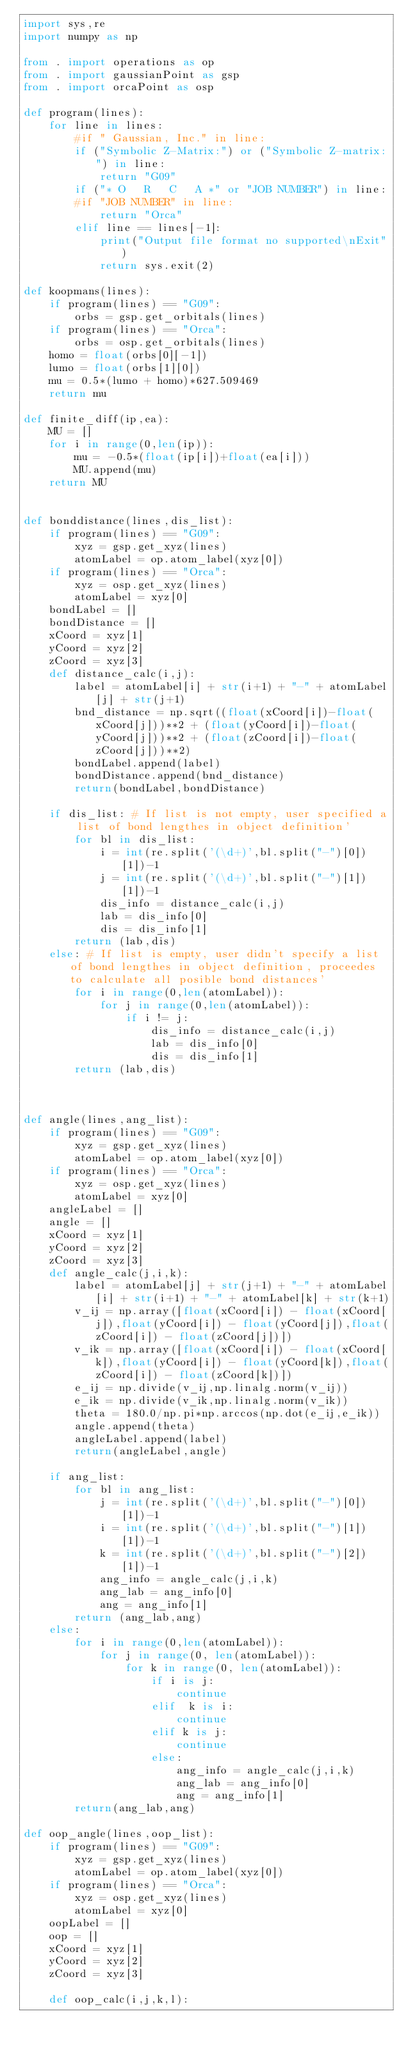Convert code to text. <code><loc_0><loc_0><loc_500><loc_500><_Python_>import sys,re
import numpy as np

from . import operations as op
from . import gaussianPoint as gsp
from . import orcaPoint as osp

def program(lines):
    for line in lines:
        #if " Gaussian, Inc." in line:
        if ("Symbolic Z-Matrix:") or ("Symbolic Z-matrix:") in line:
            return "G09"
        if ("* O   R   C   A *" or "JOB NUMBER") in line:
        #if "JOB NUMBER" in line:
            return "Orca"
        elif line == lines[-1]:
            print("Output file format no supported\nExit")
            return sys.exit(2)

def koopmans(lines):
    if program(lines) == "G09":
        orbs = gsp.get_orbitals(lines)
    if program(lines) == "Orca":
        orbs = osp.get_orbitals(lines)
    homo = float(orbs[0][-1])
    lumo = float(orbs[1][0])
    mu = 0.5*(lumo + homo)*627.509469
    return mu

def finite_diff(ip,ea):
    MU = []
    for i in range(0,len(ip)):
        mu = -0.5*(float(ip[i])+float(ea[i]))
        MU.append(mu)
    return MU


def bonddistance(lines,dis_list):
    if program(lines) == "G09":
        xyz = gsp.get_xyz(lines)
        atomLabel = op.atom_label(xyz[0])
    if program(lines) == "Orca":
        xyz = osp.get_xyz(lines)
        atomLabel = xyz[0]
    bondLabel = []
    bondDistance = []
    xCoord = xyz[1]
    yCoord = xyz[2]
    zCoord = xyz[3]
    def distance_calc(i,j):
        label = atomLabel[i] + str(i+1) + "-" + atomLabel[j] + str(j+1)
        bnd_distance = np.sqrt((float(xCoord[i])-float(xCoord[j]))**2 + (float(yCoord[i])-float(yCoord[j]))**2 + (float(zCoord[i])-float(zCoord[j]))**2)
        bondLabel.append(label)
        bondDistance.append(bnd_distance)
        return(bondLabel,bondDistance)

    if dis_list: # If list is not empty, user specified a list of bond lengthes in object definition'
        for bl in dis_list:
            i = int(re.split('(\d+)',bl.split("-")[0])[1])-1
            j = int(re.split('(\d+)',bl.split("-")[1])[1])-1
            dis_info = distance_calc(i,j)
            lab = dis_info[0]
            dis = dis_info[1]
        return (lab,dis)
    else: # If list is empty, user didn't specify a list of bond lengthes in object definition, proceedes to calculate all posible bond distances'
        for i in range(0,len(atomLabel)):
            for j in range(0,len(atomLabel)):
                if i != j:
                    dis_info = distance_calc(i,j)
                    lab = dis_info[0]
                    dis = dis_info[1]
        return (lab,dis)



def angle(lines,ang_list):
    if program(lines) == "G09":
        xyz = gsp.get_xyz(lines)
        atomLabel = op.atom_label(xyz[0])
    if program(lines) == "Orca":
        xyz = osp.get_xyz(lines)
        atomLabel = xyz[0]
    angleLabel = []
    angle = []
    xCoord = xyz[1]
    yCoord = xyz[2]
    zCoord = xyz[3]
    def angle_calc(j,i,k):
        label = atomLabel[j] + str(j+1) + "-" + atomLabel[i] + str(i+1) + "-" + atomLabel[k] + str(k+1)
        v_ij = np.array([float(xCoord[i]) - float(xCoord[j]),float(yCoord[i]) - float(yCoord[j]),float(zCoord[i]) - float(zCoord[j])])
        v_ik = np.array([float(xCoord[i]) - float(xCoord[k]),float(yCoord[i]) - float(yCoord[k]),float(zCoord[i]) - float(zCoord[k])])
        e_ij = np.divide(v_ij,np.linalg.norm(v_ij))
        e_ik = np.divide(v_ik,np.linalg.norm(v_ik))
        theta = 180.0/np.pi*np.arccos(np.dot(e_ij,e_ik))
        angle.append(theta)
        angleLabel.append(label)
        return(angleLabel,angle)

    if ang_list:
        for bl in ang_list:
            j = int(re.split('(\d+)',bl.split("-")[0])[1])-1
            i = int(re.split('(\d+)',bl.split("-")[1])[1])-1
            k = int(re.split('(\d+)',bl.split("-")[2])[1])-1
            ang_info = angle_calc(j,i,k)
            ang_lab = ang_info[0]
            ang = ang_info[1]
        return (ang_lab,ang)
    else:
        for i in range(0,len(atomLabel)):
            for j in range(0, len(atomLabel)):
                for k in range(0, len(atomLabel)):
                    if i is j:
                        continue
                    elif  k is i:
                        continue
                    elif k is j:
                        continue
                    else:
                        ang_info = angle_calc(j,i,k)
                        ang_lab = ang_info[0]
                        ang = ang_info[1]
        return(ang_lab,ang)

def oop_angle(lines,oop_list):
    if program(lines) == "G09":
        xyz = gsp.get_xyz(lines)
        atomLabel = op.atom_label(xyz[0])
    if program(lines) == "Orca":
        xyz = osp.get_xyz(lines)
        atomLabel = xyz[0]
    oopLabel = []
    oop = []
    xCoord = xyz[1]
    yCoord = xyz[2]
    zCoord = xyz[3]

    def oop_calc(i,j,k,l):</code> 